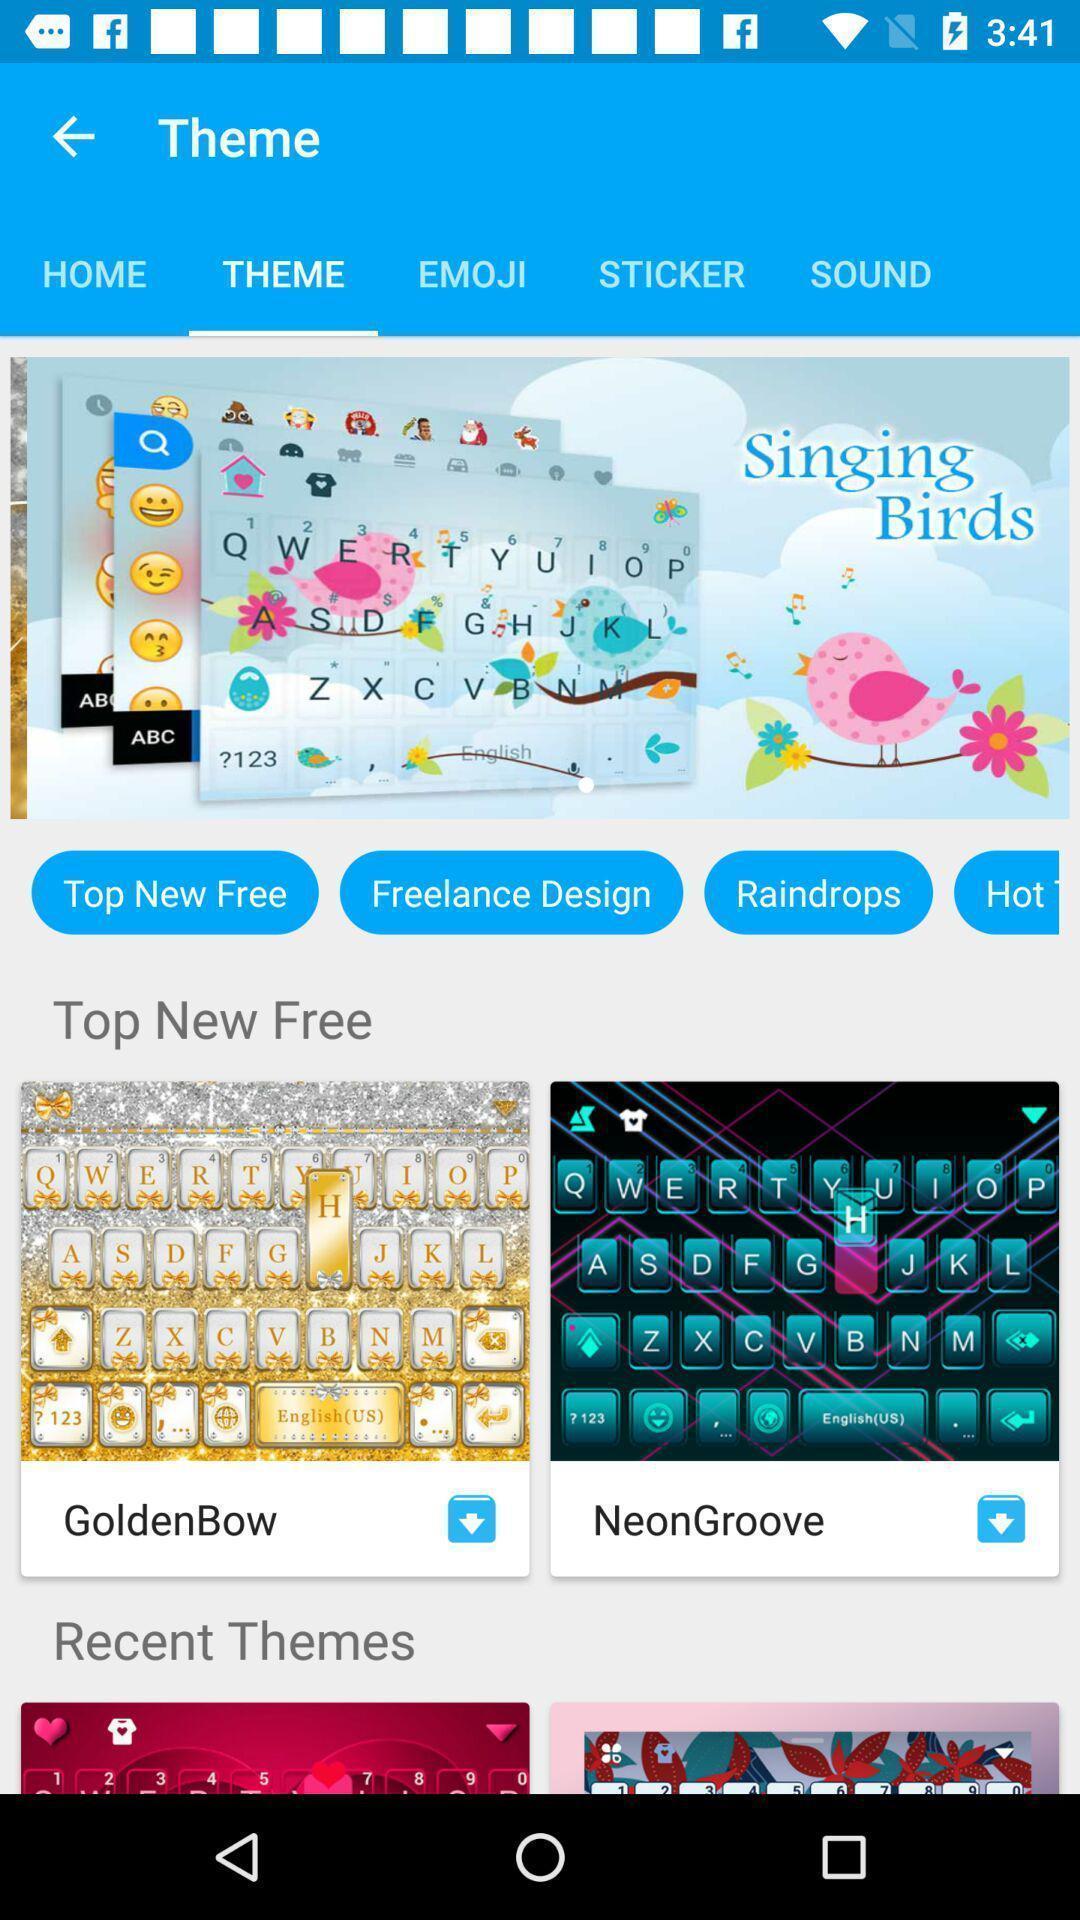Provide a description of this screenshot. Page showing the multiple theme options. 